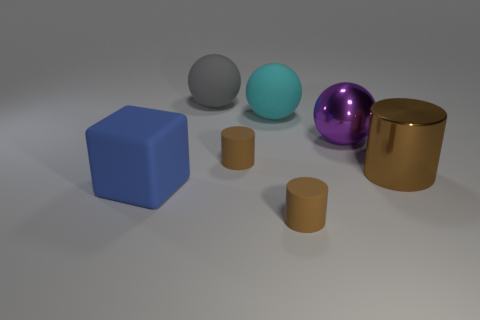Subtract all matte balls. How many balls are left? 1 Add 3 tiny cyan matte blocks. How many objects exist? 10 Subtract all cyan spheres. How many spheres are left? 2 Subtract 1 blocks. How many blocks are left? 0 Subtract 1 blue cubes. How many objects are left? 6 Subtract all cubes. How many objects are left? 6 Subtract all blue balls. Subtract all green cubes. How many balls are left? 3 Subtract all tiny cyan rubber cylinders. Subtract all big matte blocks. How many objects are left? 6 Add 3 gray rubber balls. How many gray rubber balls are left? 4 Add 1 big blue objects. How many big blue objects exist? 2 